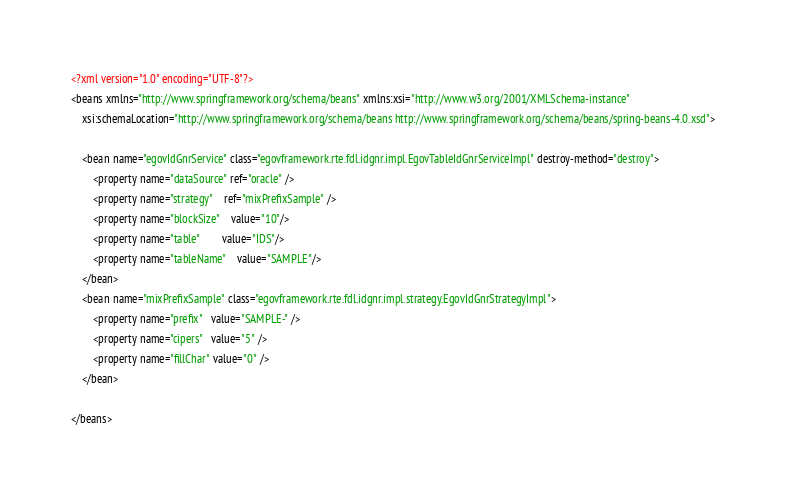<code> <loc_0><loc_0><loc_500><loc_500><_XML_><?xml version="1.0" encoding="UTF-8"?>
<beans xmlns="http://www.springframework.org/schema/beans" xmlns:xsi="http://www.w3.org/2001/XMLSchema-instance"
	xsi:schemaLocation="http://www.springframework.org/schema/beans http://www.springframework.org/schema/beans/spring-beans-4.0.xsd">

	<bean name="egovIdGnrService" class="egovframework.rte.fdl.idgnr.impl.EgovTableIdGnrServiceImpl" destroy-method="destroy">
		<property name="dataSource" ref="oracle" />
		<property name="strategy" 	ref="mixPrefixSample" />
		<property name="blockSize" 	value="10"/>
		<property name="table"	   	value="IDS"/>
		<property name="tableName"	value="SAMPLE"/>
	</bean>
	<bean name="mixPrefixSample" class="egovframework.rte.fdl.idgnr.impl.strategy.EgovIdGnrStrategyImpl">
		<property name="prefix"   value="SAMPLE-" />
		<property name="cipers"   value="5" />
		<property name="fillChar" value="0" />
	</bean>	
			
</beans>
</code> 